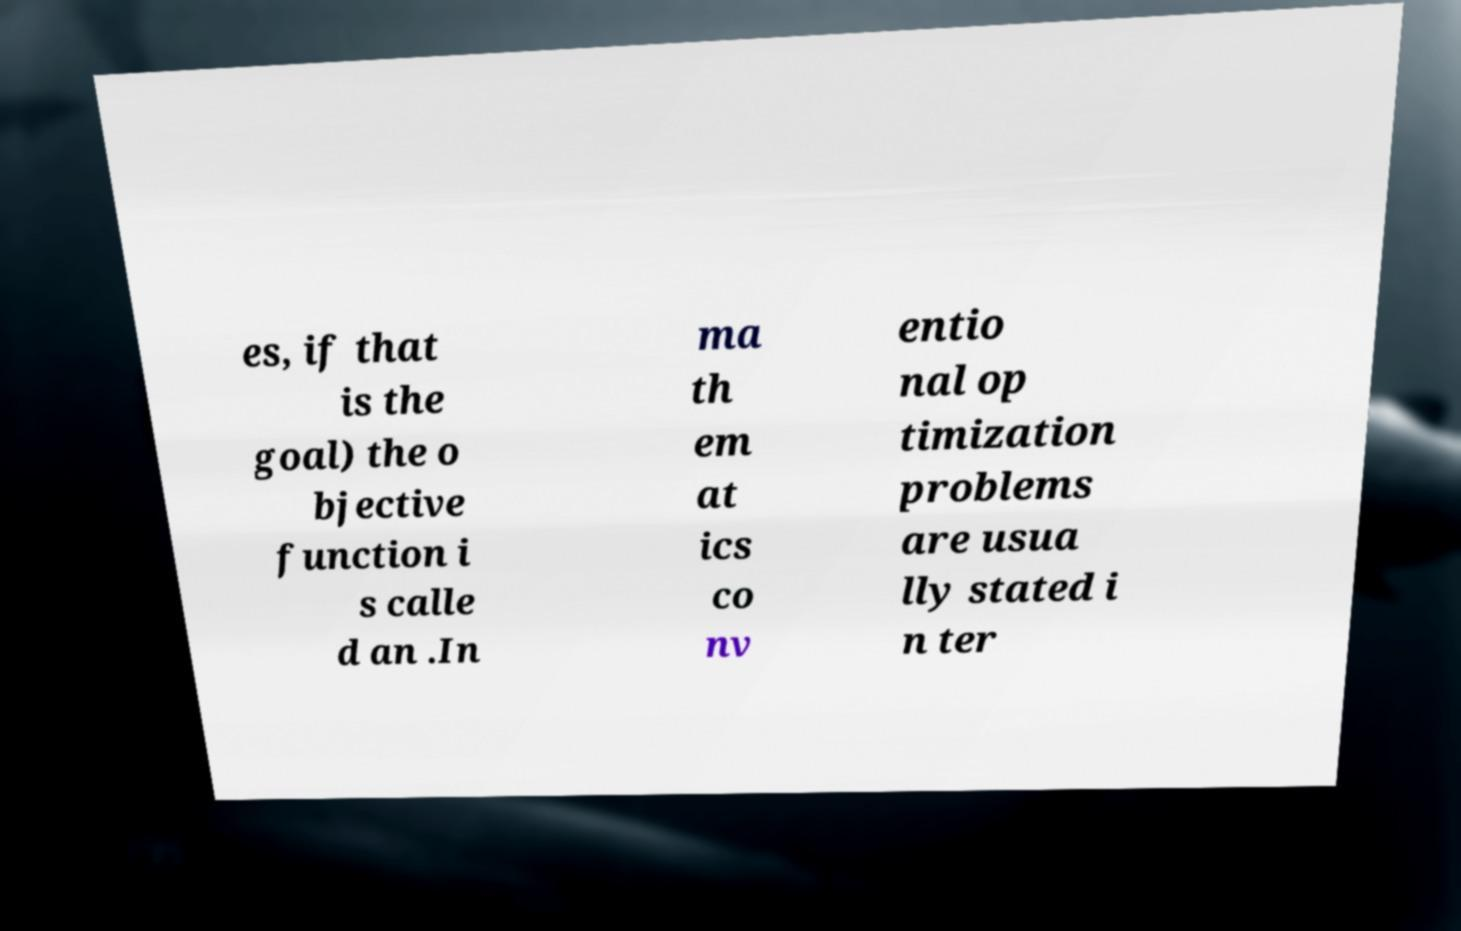Please identify and transcribe the text found in this image. es, if that is the goal) the o bjective function i s calle d an .In ma th em at ics co nv entio nal op timization problems are usua lly stated i n ter 